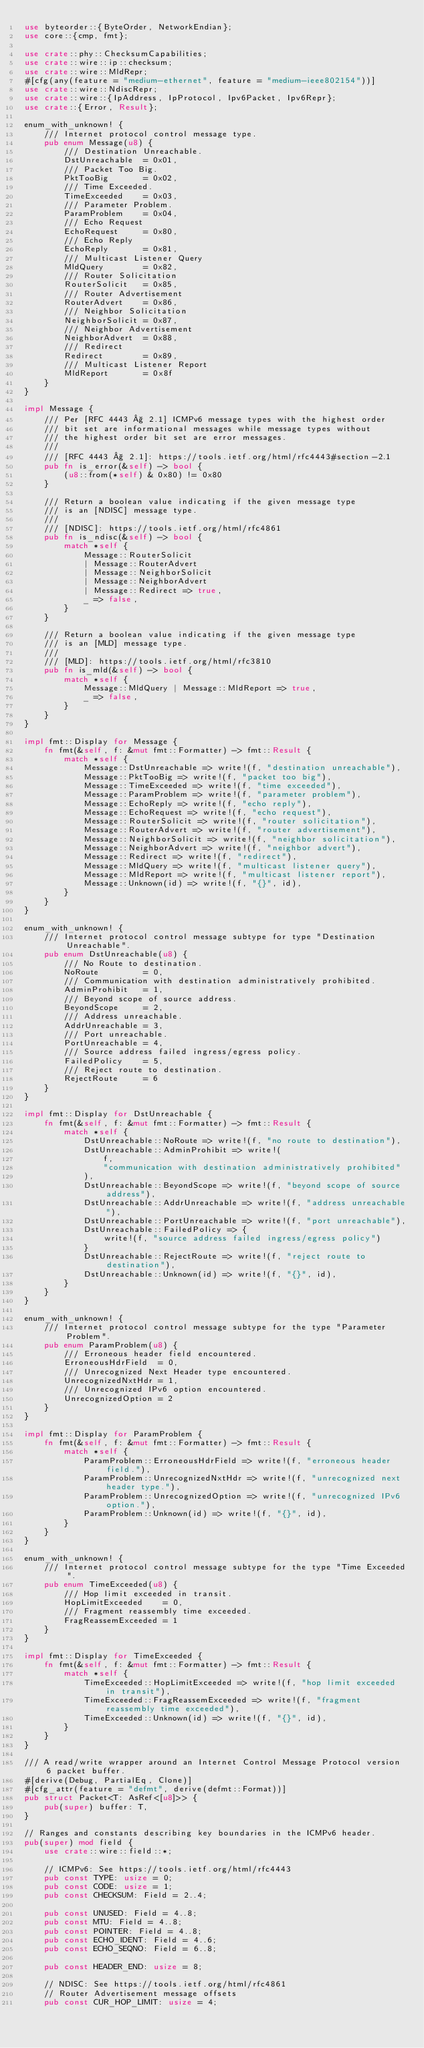Convert code to text. <code><loc_0><loc_0><loc_500><loc_500><_Rust_>use byteorder::{ByteOrder, NetworkEndian};
use core::{cmp, fmt};

use crate::phy::ChecksumCapabilities;
use crate::wire::ip::checksum;
use crate::wire::MldRepr;
#[cfg(any(feature = "medium-ethernet", feature = "medium-ieee802154"))]
use crate::wire::NdiscRepr;
use crate::wire::{IpAddress, IpProtocol, Ipv6Packet, Ipv6Repr};
use crate::{Error, Result};

enum_with_unknown! {
    /// Internet protocol control message type.
    pub enum Message(u8) {
        /// Destination Unreachable.
        DstUnreachable  = 0x01,
        /// Packet Too Big.
        PktTooBig       = 0x02,
        /// Time Exceeded.
        TimeExceeded    = 0x03,
        /// Parameter Problem.
        ParamProblem    = 0x04,
        /// Echo Request
        EchoRequest     = 0x80,
        /// Echo Reply
        EchoReply       = 0x81,
        /// Multicast Listener Query
        MldQuery        = 0x82,
        /// Router Solicitation
        RouterSolicit   = 0x85,
        /// Router Advertisement
        RouterAdvert    = 0x86,
        /// Neighbor Solicitation
        NeighborSolicit = 0x87,
        /// Neighbor Advertisement
        NeighborAdvert  = 0x88,
        /// Redirect
        Redirect        = 0x89,
        /// Multicast Listener Report
        MldReport       = 0x8f
    }
}

impl Message {
    /// Per [RFC 4443 § 2.1] ICMPv6 message types with the highest order
    /// bit set are informational messages while message types without
    /// the highest order bit set are error messages.
    ///
    /// [RFC 4443 § 2.1]: https://tools.ietf.org/html/rfc4443#section-2.1
    pub fn is_error(&self) -> bool {
        (u8::from(*self) & 0x80) != 0x80
    }

    /// Return a boolean value indicating if the given message type
    /// is an [NDISC] message type.
    ///
    /// [NDISC]: https://tools.ietf.org/html/rfc4861
    pub fn is_ndisc(&self) -> bool {
        match *self {
            Message::RouterSolicit
            | Message::RouterAdvert
            | Message::NeighborSolicit
            | Message::NeighborAdvert
            | Message::Redirect => true,
            _ => false,
        }
    }

    /// Return a boolean value indicating if the given message type
    /// is an [MLD] message type.
    ///
    /// [MLD]: https://tools.ietf.org/html/rfc3810
    pub fn is_mld(&self) -> bool {
        match *self {
            Message::MldQuery | Message::MldReport => true,
            _ => false,
        }
    }
}

impl fmt::Display for Message {
    fn fmt(&self, f: &mut fmt::Formatter) -> fmt::Result {
        match *self {
            Message::DstUnreachable => write!(f, "destination unreachable"),
            Message::PktTooBig => write!(f, "packet too big"),
            Message::TimeExceeded => write!(f, "time exceeded"),
            Message::ParamProblem => write!(f, "parameter problem"),
            Message::EchoReply => write!(f, "echo reply"),
            Message::EchoRequest => write!(f, "echo request"),
            Message::RouterSolicit => write!(f, "router solicitation"),
            Message::RouterAdvert => write!(f, "router advertisement"),
            Message::NeighborSolicit => write!(f, "neighbor solicitation"),
            Message::NeighborAdvert => write!(f, "neighbor advert"),
            Message::Redirect => write!(f, "redirect"),
            Message::MldQuery => write!(f, "multicast listener query"),
            Message::MldReport => write!(f, "multicast listener report"),
            Message::Unknown(id) => write!(f, "{}", id),
        }
    }
}

enum_with_unknown! {
    /// Internet protocol control message subtype for type "Destination Unreachable".
    pub enum DstUnreachable(u8) {
        /// No Route to destination.
        NoRoute         = 0,
        /// Communication with destination administratively prohibited.
        AdminProhibit   = 1,
        /// Beyond scope of source address.
        BeyondScope     = 2,
        /// Address unreachable.
        AddrUnreachable = 3,
        /// Port unreachable.
        PortUnreachable = 4,
        /// Source address failed ingress/egress policy.
        FailedPolicy    = 5,
        /// Reject route to destination.
        RejectRoute     = 6
    }
}

impl fmt::Display for DstUnreachable {
    fn fmt(&self, f: &mut fmt::Formatter) -> fmt::Result {
        match *self {
            DstUnreachable::NoRoute => write!(f, "no route to destination"),
            DstUnreachable::AdminProhibit => write!(
                f,
                "communication with destination administratively prohibited"
            ),
            DstUnreachable::BeyondScope => write!(f, "beyond scope of source address"),
            DstUnreachable::AddrUnreachable => write!(f, "address unreachable"),
            DstUnreachable::PortUnreachable => write!(f, "port unreachable"),
            DstUnreachable::FailedPolicy => {
                write!(f, "source address failed ingress/egress policy")
            }
            DstUnreachable::RejectRoute => write!(f, "reject route to destination"),
            DstUnreachable::Unknown(id) => write!(f, "{}", id),
        }
    }
}

enum_with_unknown! {
    /// Internet protocol control message subtype for the type "Parameter Problem".
    pub enum ParamProblem(u8) {
        /// Erroneous header field encountered.
        ErroneousHdrField  = 0,
        /// Unrecognized Next Header type encountered.
        UnrecognizedNxtHdr = 1,
        /// Unrecognized IPv6 option encountered.
        UnrecognizedOption = 2
    }
}

impl fmt::Display for ParamProblem {
    fn fmt(&self, f: &mut fmt::Formatter) -> fmt::Result {
        match *self {
            ParamProblem::ErroneousHdrField => write!(f, "erroneous header field."),
            ParamProblem::UnrecognizedNxtHdr => write!(f, "unrecognized next header type."),
            ParamProblem::UnrecognizedOption => write!(f, "unrecognized IPv6 option."),
            ParamProblem::Unknown(id) => write!(f, "{}", id),
        }
    }
}

enum_with_unknown! {
    /// Internet protocol control message subtype for the type "Time Exceeded".
    pub enum TimeExceeded(u8) {
        /// Hop limit exceeded in transit.
        HopLimitExceeded    = 0,
        /// Fragment reassembly time exceeded.
        FragReassemExceeded = 1
    }
}

impl fmt::Display for TimeExceeded {
    fn fmt(&self, f: &mut fmt::Formatter) -> fmt::Result {
        match *self {
            TimeExceeded::HopLimitExceeded => write!(f, "hop limit exceeded in transit"),
            TimeExceeded::FragReassemExceeded => write!(f, "fragment reassembly time exceeded"),
            TimeExceeded::Unknown(id) => write!(f, "{}", id),
        }
    }
}

/// A read/write wrapper around an Internet Control Message Protocol version 6 packet buffer.
#[derive(Debug, PartialEq, Clone)]
#[cfg_attr(feature = "defmt", derive(defmt::Format))]
pub struct Packet<T: AsRef<[u8]>> {
    pub(super) buffer: T,
}

// Ranges and constants describing key boundaries in the ICMPv6 header.
pub(super) mod field {
    use crate::wire::field::*;

    // ICMPv6: See https://tools.ietf.org/html/rfc4443
    pub const TYPE: usize = 0;
    pub const CODE: usize = 1;
    pub const CHECKSUM: Field = 2..4;

    pub const UNUSED: Field = 4..8;
    pub const MTU: Field = 4..8;
    pub const POINTER: Field = 4..8;
    pub const ECHO_IDENT: Field = 4..6;
    pub const ECHO_SEQNO: Field = 6..8;

    pub const HEADER_END: usize = 8;

    // NDISC: See https://tools.ietf.org/html/rfc4861
    // Router Advertisement message offsets
    pub const CUR_HOP_LIMIT: usize = 4;</code> 